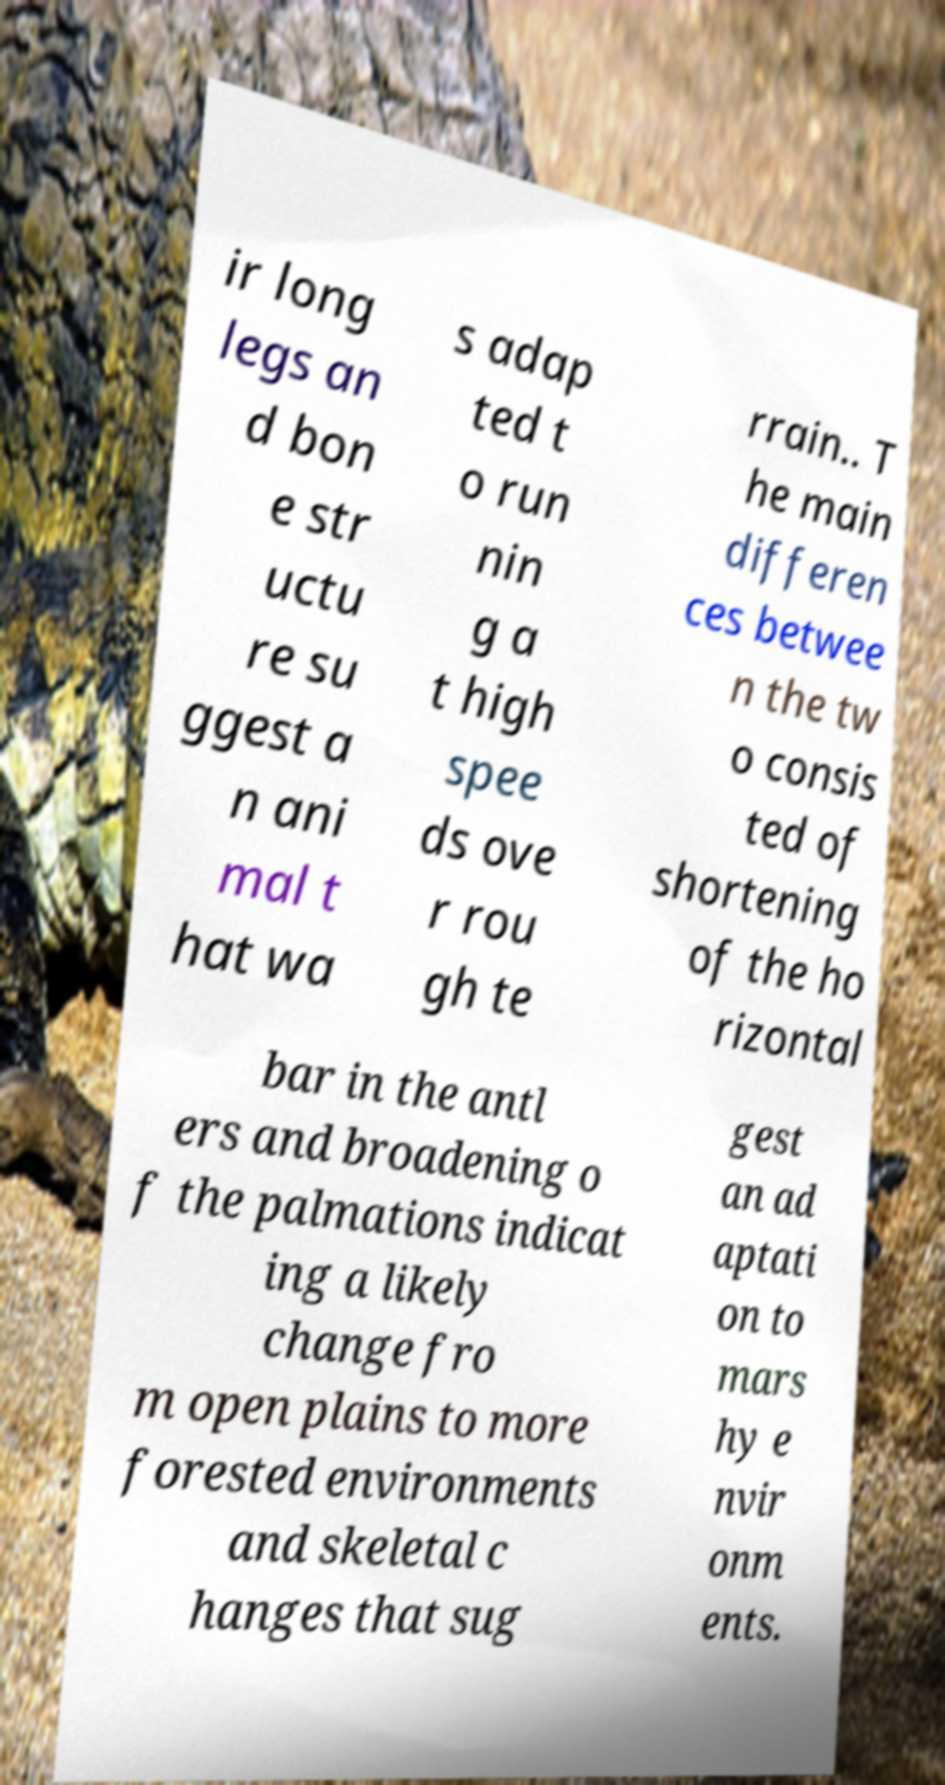I need the written content from this picture converted into text. Can you do that? ir long legs an d bon e str uctu re su ggest a n ani mal t hat wa s adap ted t o run nin g a t high spee ds ove r rou gh te rrain.. T he main differen ces betwee n the tw o consis ted of shortening of the ho rizontal bar in the antl ers and broadening o f the palmations indicat ing a likely change fro m open plains to more forested environments and skeletal c hanges that sug gest an ad aptati on to mars hy e nvir onm ents. 